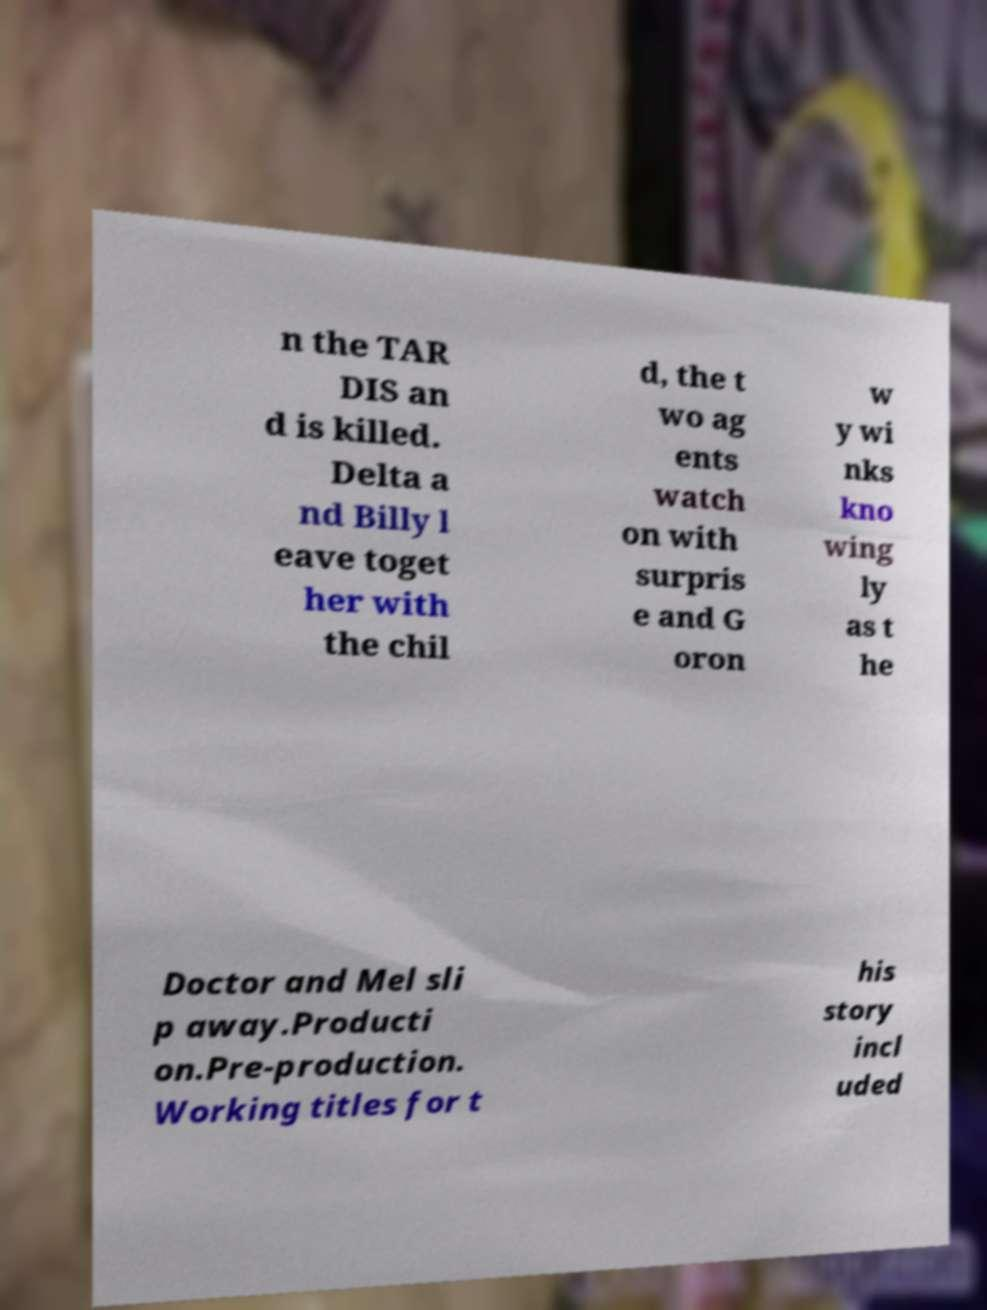Could you extract and type out the text from this image? n the TAR DIS an d is killed. Delta a nd Billy l eave toget her with the chil d, the t wo ag ents watch on with surpris e and G oron w y wi nks kno wing ly as t he Doctor and Mel sli p away.Producti on.Pre-production. Working titles for t his story incl uded 